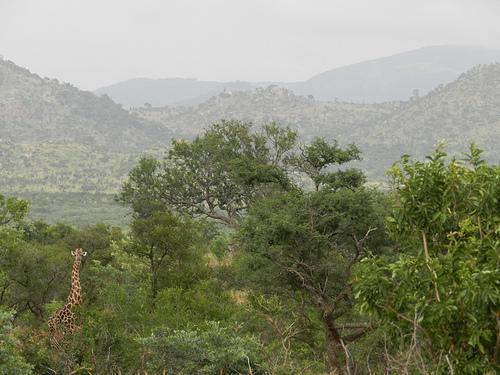How many animals?
Give a very brief answer. 1. 